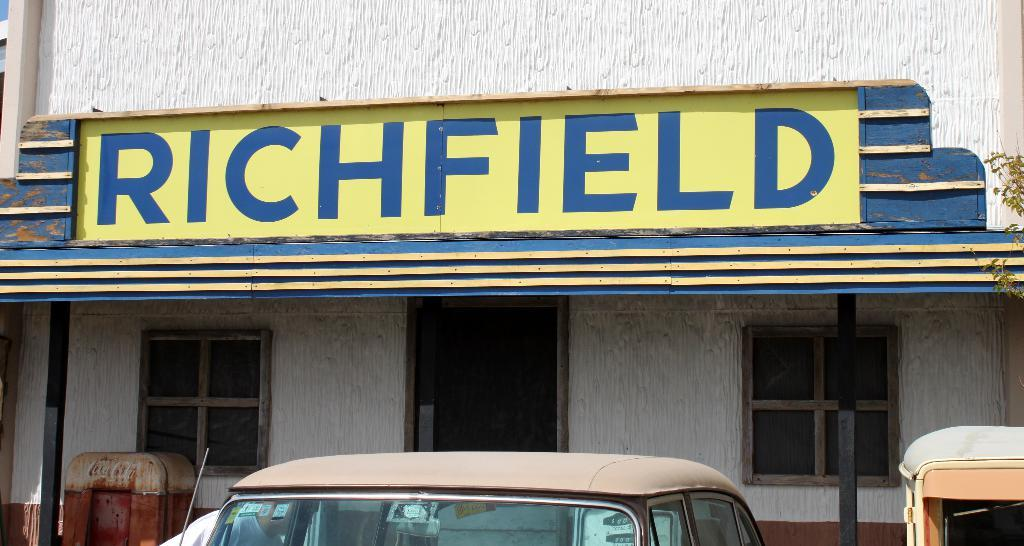What type of structure is visible in the image? There is a building in the image. What can be seen on the wall of the building? There is text on the wall of the building. What is located at the bottom of the image? There are vehicles at the bottom of the image. What is the main feature in the middle of the image? There is an entrance gate in the middle of the image. What architectural elements are present in the image? There are windows in the image. What type of wave can be seen crashing against the building in the image? There is no wave present in the image; it features a building with text on the wall, vehicles, an entrance gate, and windows. Who is the minister in the image? There is no minister present in the image. 